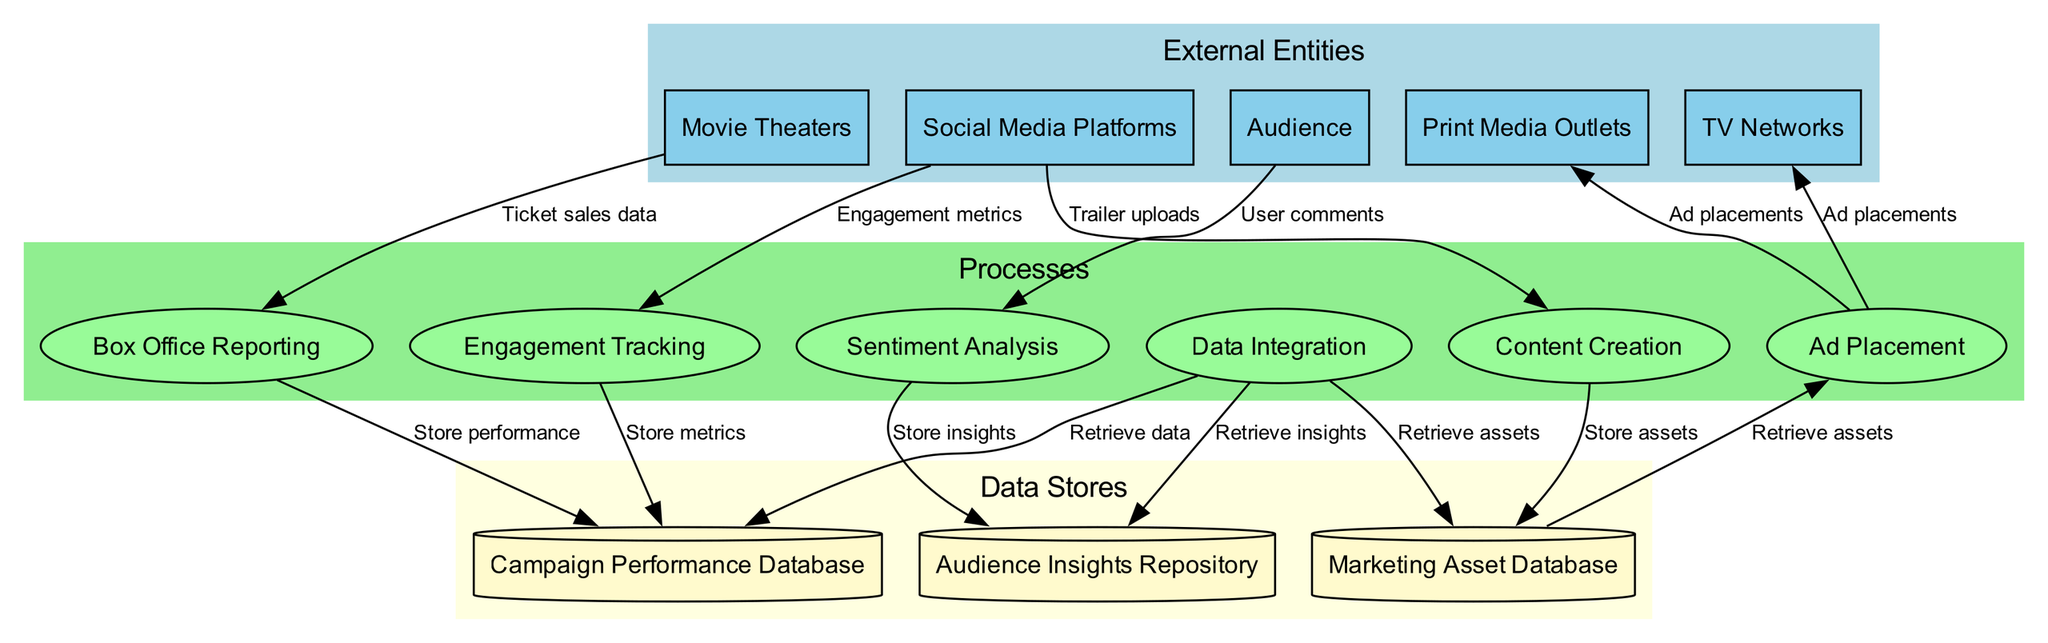What are the external entities in the diagram? The diagram includes five external entities: Social Media Platforms, TV Networks, Print Media Outlets, Movie Theaters, and Audience. Each of these entities represents a source or target of data flow related to the movie marketing campaign.
Answer: Social Media Platforms, TV Networks, Print Media Outlets, Movie Theaters, Audience How many processes are illustrated in the diagram? The diagram shows six processes: Content Creation, Ad Placement, Sentiment Analysis, Engagement Tracking, Box Office Reporting, and Data Integration. The total count is obtained by counting each distinct process in the processes section.
Answer: Six Which process receives data from Audience? The Sentiment Analysis process receives data from the Audience in the form of user comments. This connection is explicitly shown in the diagram as a data flow from Audience to Sentiment Analysis.
Answer: Sentiment Analysis What data flows into the Campaign Performance Database? The Campaign Performance Database receives data flows from Engagement Tracking, Box Office Reporting, and Data Integration, which store engagement metrics, ticket sales data, and retrieval of data, respectively.
Answer: Engagement metrics, Ticket sales data, Retrieve data What is the relationship between Ad Placement and TV Networks? The Ad Placement process sends ad placements to TV Networks. This is depicted in the diagram as a directed edge from the Ad Placement process to the TV Networks external entity, indicating the direction of data flow.
Answer: Ad placements How is data stored after Sentiment Analysis? After the Sentiment Analysis process is completed, the insights gained are stored in the Audience Insights Repository. This relationship is illustrated in the diagram as a directed edge from Sentiment Analysis to Audience Insights Repository, indicating that data is stored post-analysis.
Answer: Store insights Which external entity provides engagement metrics? Social Media Platforms provide engagement metrics to the Engagement Tracking process. This data flow is represented in the diagram with an edge showing the direction from Social Media Platforms to Engagement Tracking.
Answer: Social Media Platforms What is stored in the Marketing Asset Database? The Marketing Asset Database stores marketing assets that are created through the Content Creation process. This relationship is shown as a directed edge from Content Creation to Marketing Asset Database.
Answer: Store assets How many data stores are present in the diagram? The diagram lists three data stores: Marketing Asset Database, Audience Insights Repository, and Campaign Performance Database. By counting these, we derive the total number of data stores present.
Answer: Three 